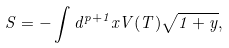Convert formula to latex. <formula><loc_0><loc_0><loc_500><loc_500>S = - \int d ^ { p + 1 } x V ( T ) \sqrt { 1 + y } ,</formula> 